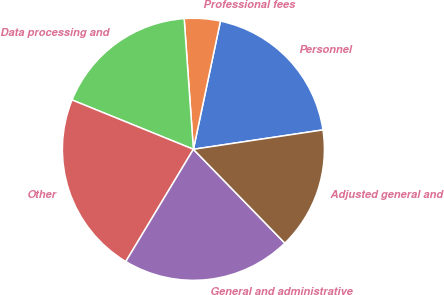Convert chart. <chart><loc_0><loc_0><loc_500><loc_500><pie_chart><fcel>Personnel<fcel>Professional fees<fcel>Data processing and<fcel>Other<fcel>General and administrative<fcel>Adjusted general and<nl><fcel>19.33%<fcel>4.43%<fcel>17.73%<fcel>22.52%<fcel>20.92%<fcel>15.07%<nl></chart> 